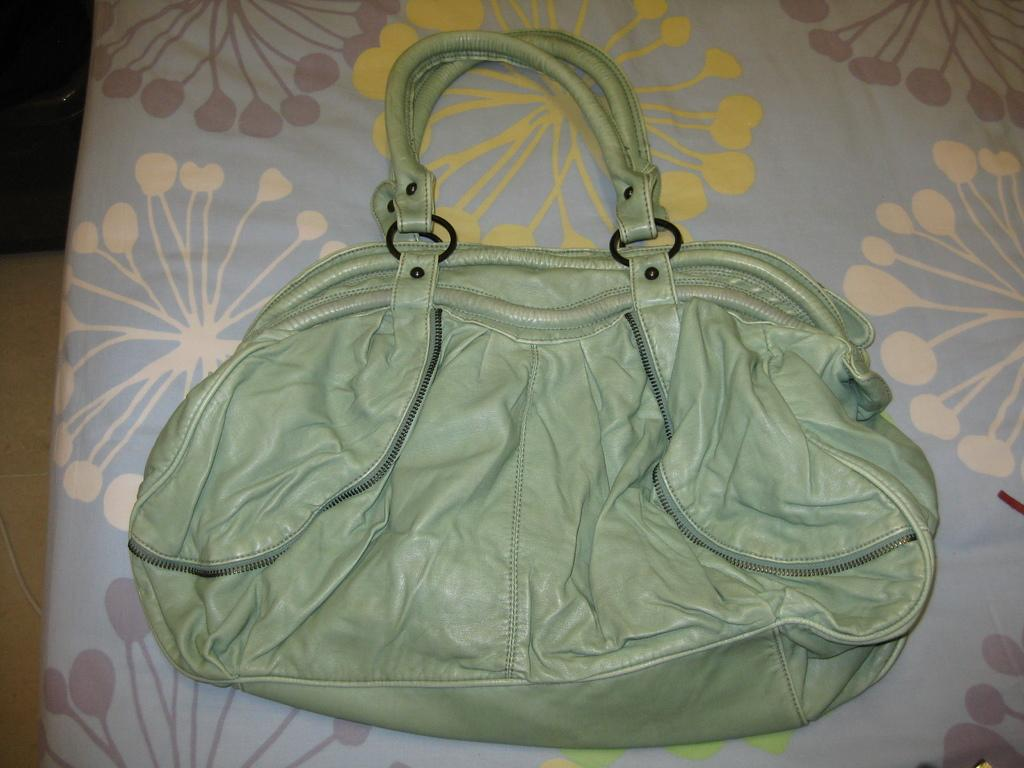What piece of furniture is present in the image? There is a bed in the image. What object is placed on the bed? There is a handbag on the bed. What type of crate is being used to transport the car in the image? There is no crate or car present in the image; it only features a bed and a handbag. 